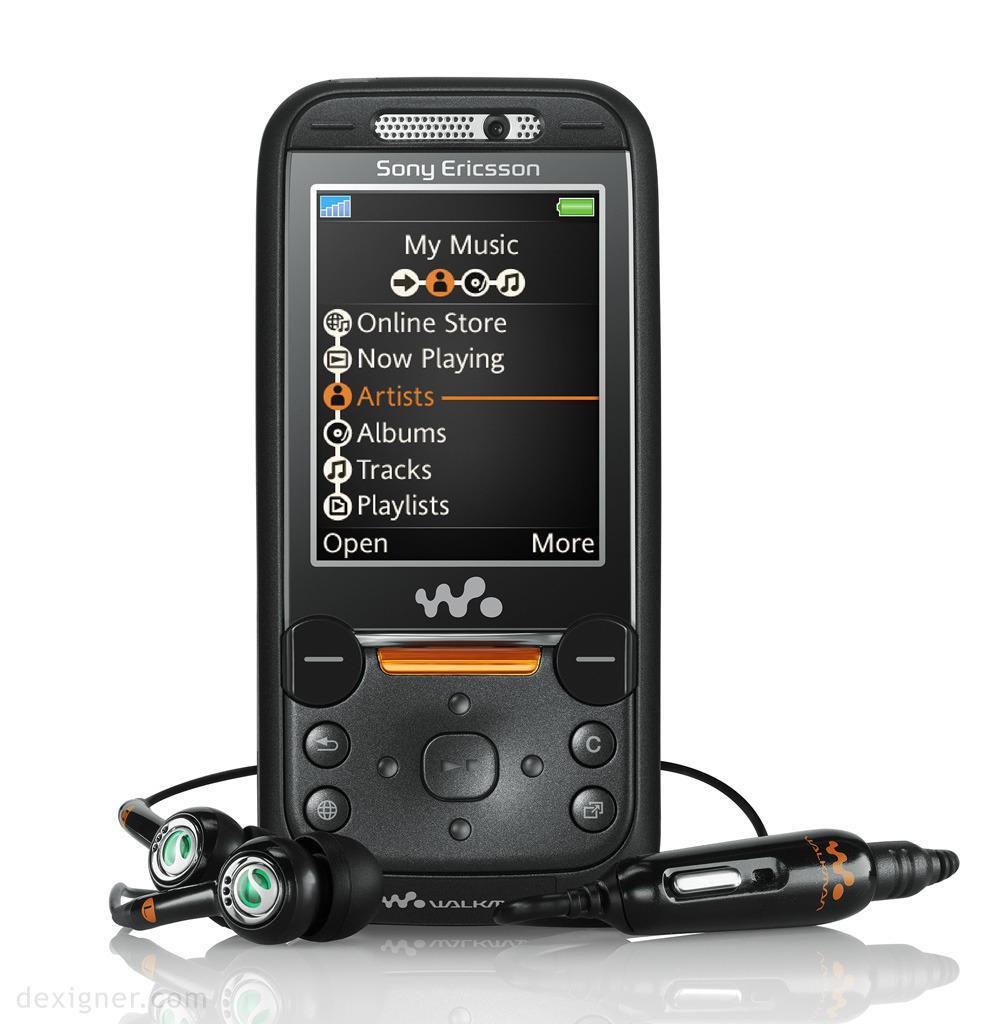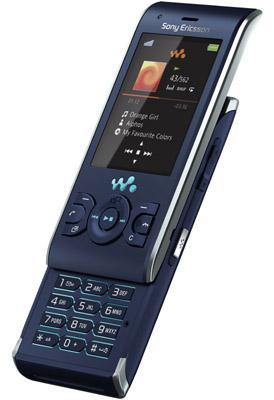The first image is the image on the left, the second image is the image on the right. Assess this claim about the two images: "The phone in the image on the right is in the slide out position.". Correct or not? Answer yes or no. Yes. The first image is the image on the left, the second image is the image on the right. Analyze the images presented: Is the assertion "Each image contains one device, each device has a vertical rectangular screen, and one device is shown with its front sliding up to reveal the key pad." valid? Answer yes or no. Yes. 